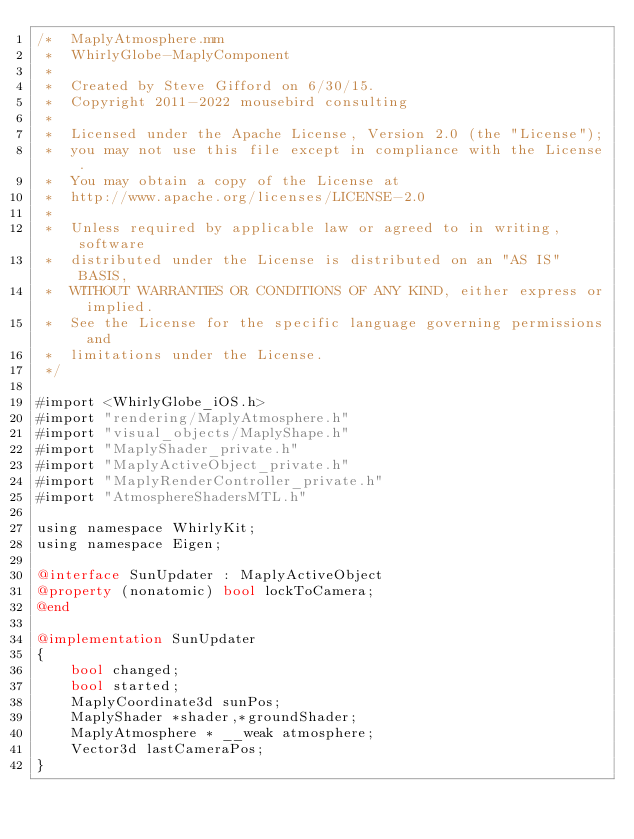Convert code to text. <code><loc_0><loc_0><loc_500><loc_500><_ObjectiveC_>/*  MaplyAtmosphere.mm
 *  WhirlyGlobe-MaplyComponent
 *
 *  Created by Steve Gifford on 6/30/15.
 *  Copyright 2011-2022 mousebird consulting
 *
 *  Licensed under the Apache License, Version 2.0 (the "License");
 *  you may not use this file except in compliance with the License.
 *  You may obtain a copy of the License at
 *  http://www.apache.org/licenses/LICENSE-2.0
 *
 *  Unless required by applicable law or agreed to in writing, software
 *  distributed under the License is distributed on an "AS IS" BASIS,
 *  WITHOUT WARRANTIES OR CONDITIONS OF ANY KIND, either express or implied.
 *  See the License for the specific language governing permissions and
 *  limitations under the License.
 */

#import <WhirlyGlobe_iOS.h>
#import "rendering/MaplyAtmosphere.h"
#import "visual_objects/MaplyShape.h"
#import "MaplyShader_private.h"
#import "MaplyActiveObject_private.h"
#import "MaplyRenderController_private.h"
#import "AtmosphereShadersMTL.h"

using namespace WhirlyKit;
using namespace Eigen;

@interface SunUpdater : MaplyActiveObject
@property (nonatomic) bool lockToCamera;
@end

@implementation SunUpdater
{
    bool changed;
    bool started;
    MaplyCoordinate3d sunPos;
    MaplyShader *shader,*groundShader;
    MaplyAtmosphere * __weak atmosphere;
    Vector3d lastCameraPos;
}
</code> 